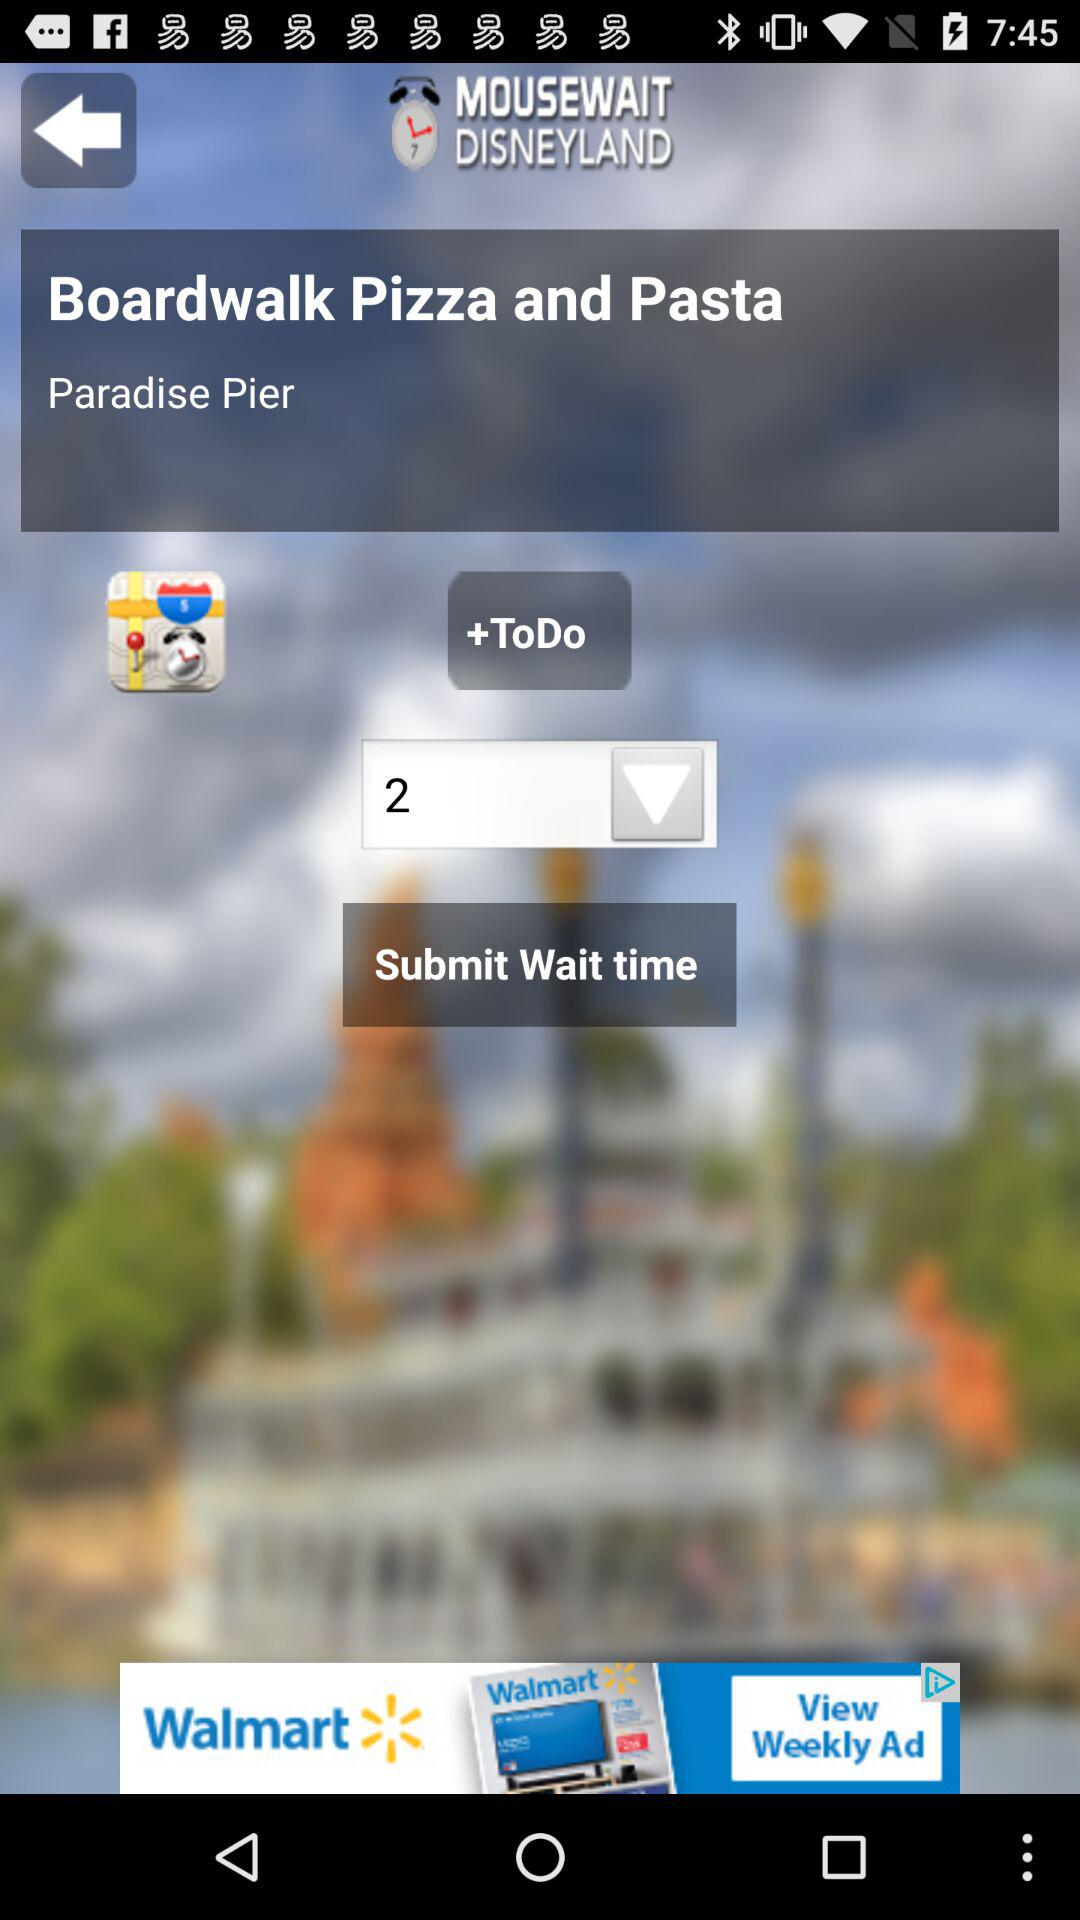What is the submit wait time? The submit wait time is 2. 